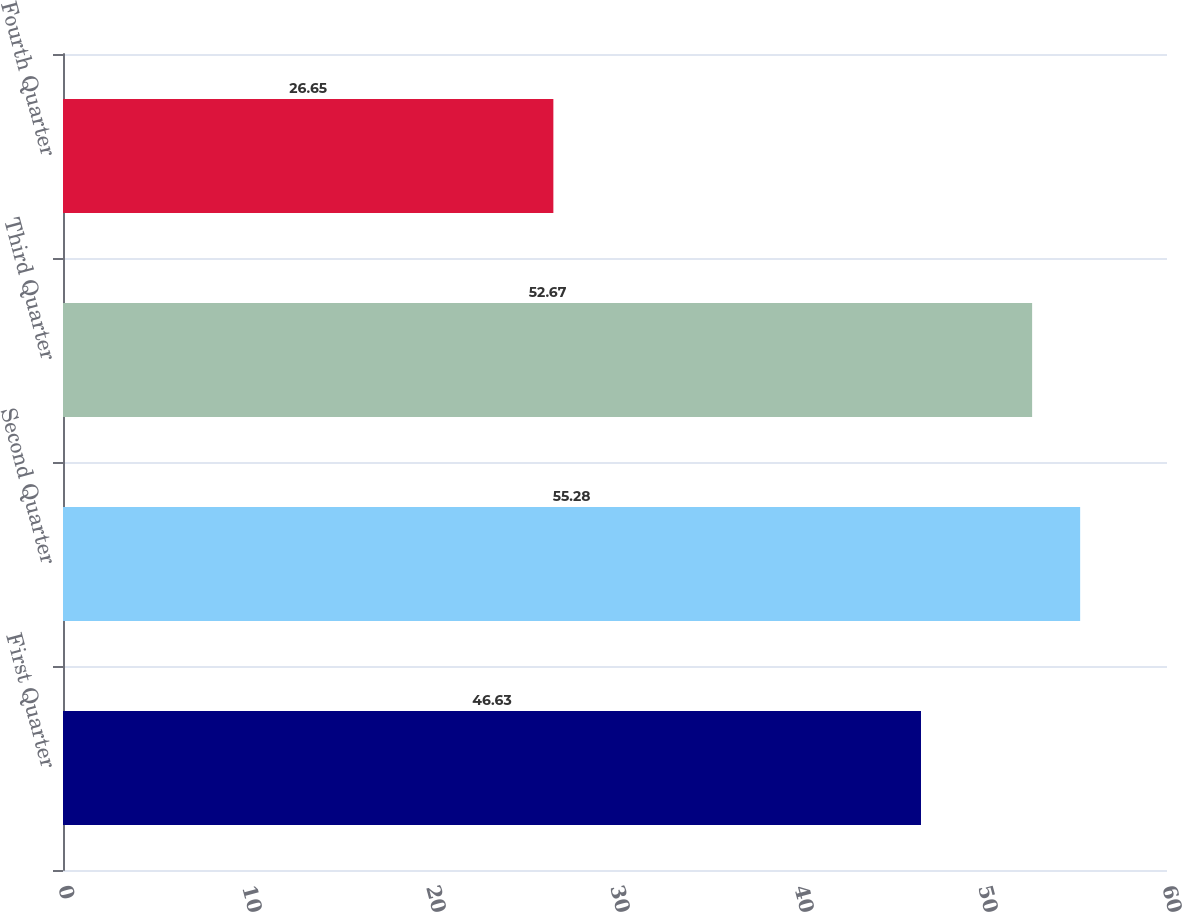Convert chart to OTSL. <chart><loc_0><loc_0><loc_500><loc_500><bar_chart><fcel>First Quarter<fcel>Second Quarter<fcel>Third Quarter<fcel>Fourth Quarter<nl><fcel>46.63<fcel>55.28<fcel>52.67<fcel>26.65<nl></chart> 